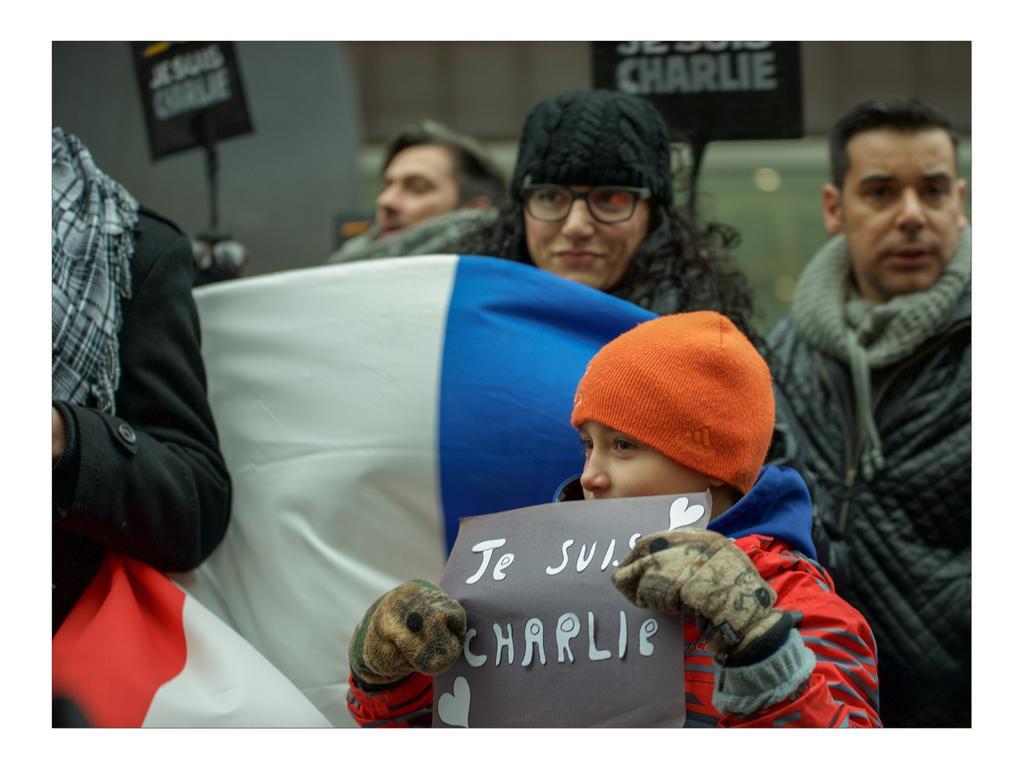Describe this image in one or two sentences. In this image I can see few people with different color dresses. I can see few people with the caps. And one person is holding the paper. In the back I can see two black color boards and something is written on it. In the background I can see the wall. 